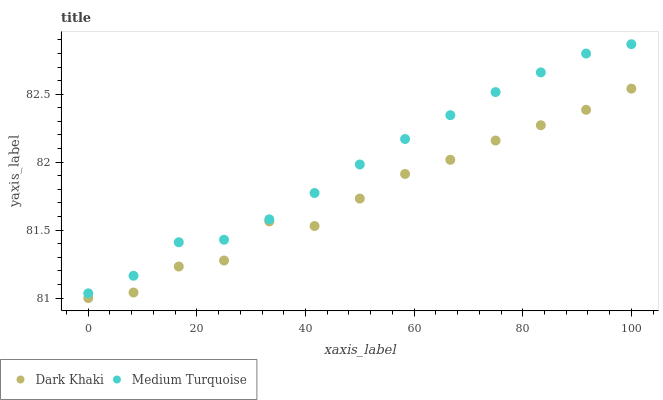Does Dark Khaki have the minimum area under the curve?
Answer yes or no. Yes. Does Medium Turquoise have the maximum area under the curve?
Answer yes or no. Yes. Does Medium Turquoise have the minimum area under the curve?
Answer yes or no. No. Is Medium Turquoise the smoothest?
Answer yes or no. Yes. Is Dark Khaki the roughest?
Answer yes or no. Yes. Is Medium Turquoise the roughest?
Answer yes or no. No. Does Dark Khaki have the lowest value?
Answer yes or no. Yes. Does Medium Turquoise have the lowest value?
Answer yes or no. No. Does Medium Turquoise have the highest value?
Answer yes or no. Yes. Is Dark Khaki less than Medium Turquoise?
Answer yes or no. Yes. Is Medium Turquoise greater than Dark Khaki?
Answer yes or no. Yes. Does Dark Khaki intersect Medium Turquoise?
Answer yes or no. No. 